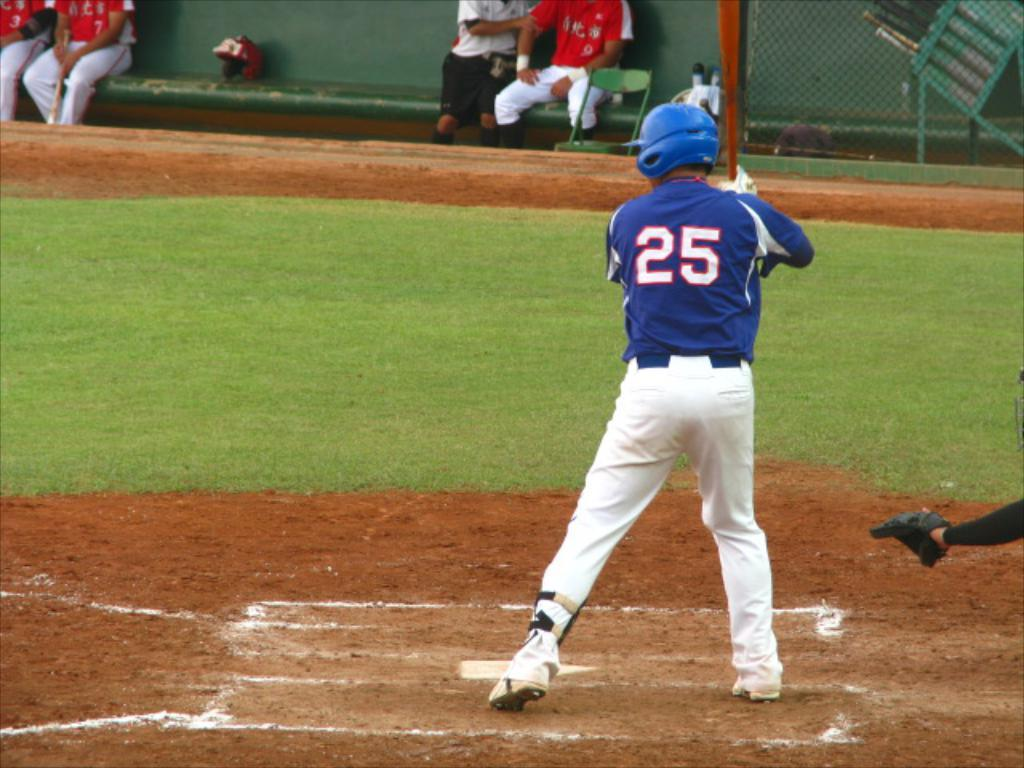Provide a one-sentence caption for the provided image. Number 25 is at home base about to swing his bat. 